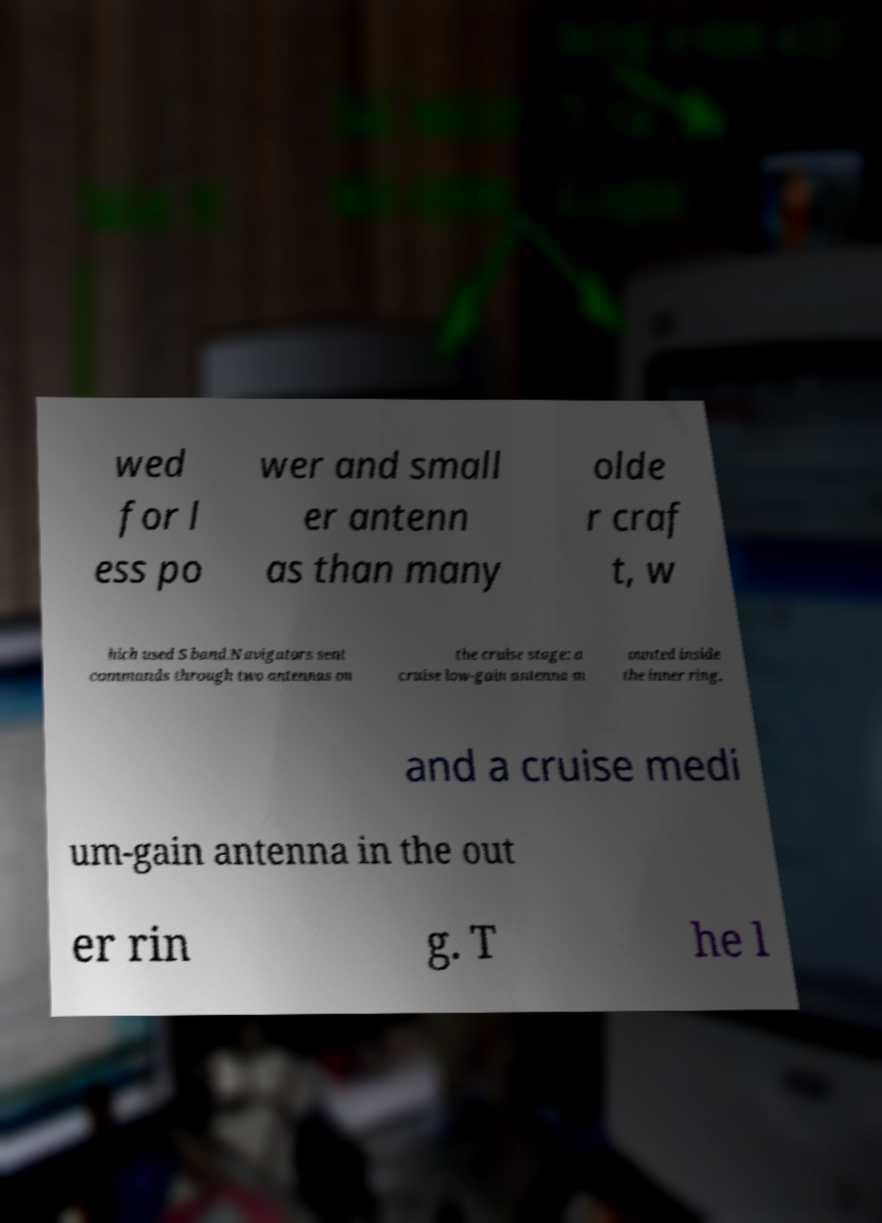What messages or text are displayed in this image? I need them in a readable, typed format. wed for l ess po wer and small er antenn as than many olde r craf t, w hich used S band.Navigators sent commands through two antennas on the cruise stage: a cruise low-gain antenna m ounted inside the inner ring, and a cruise medi um-gain antenna in the out er rin g. T he l 